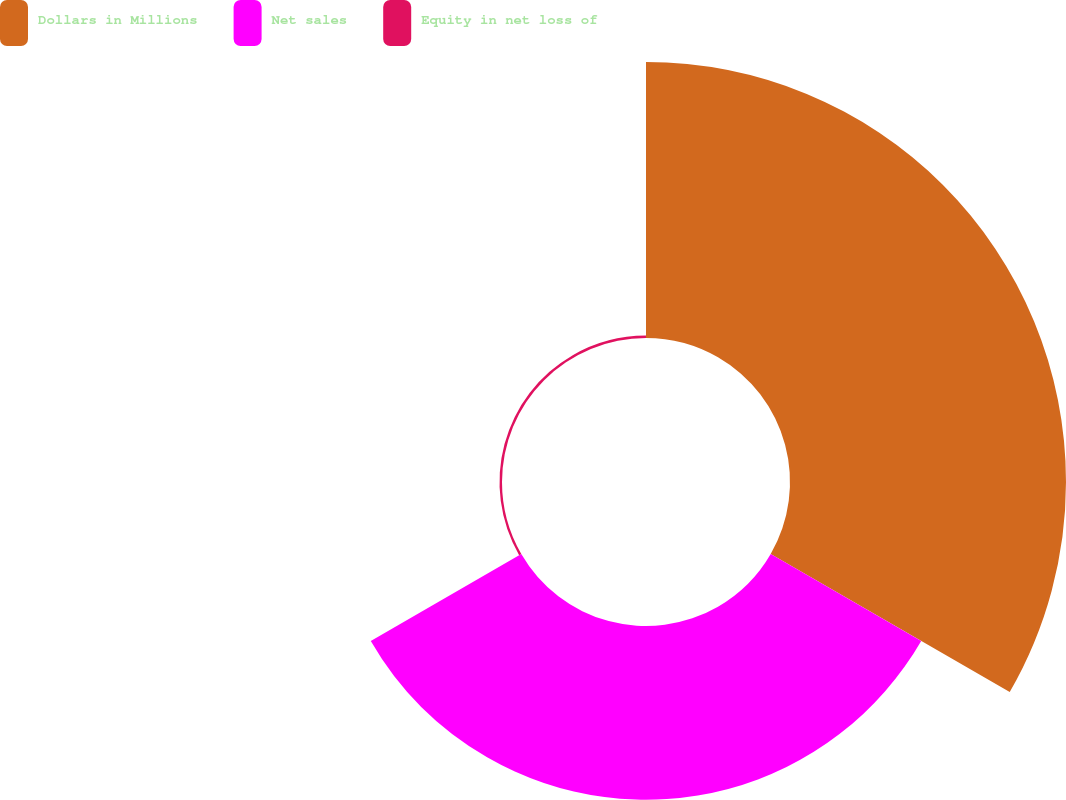<chart> <loc_0><loc_0><loc_500><loc_500><pie_chart><fcel>Dollars in Millions<fcel>Net sales<fcel>Equity in net loss of<nl><fcel>61.03%<fcel>38.43%<fcel>0.55%<nl></chart> 